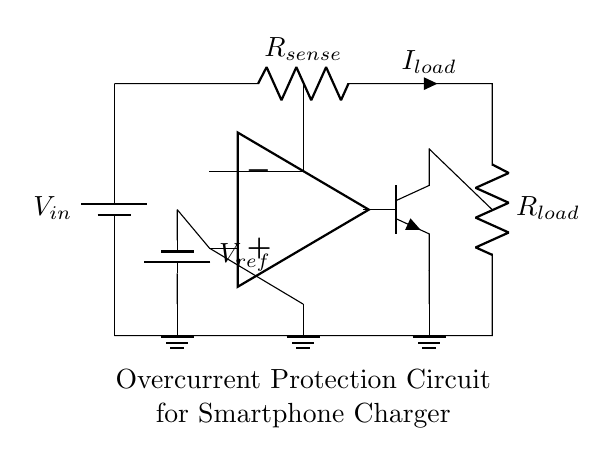What is the function of R sense? R sense is used to measure the current flowing through it, generating a voltage drop proportional to the load current. This voltage is crucial for comparing against a reference voltage to trigger overcurrent protection.
Answer: Current measurement What component is used to limit overcurrent? The transistor is employed to cut off or limit the current when the sensed value exceeds a certain threshold set by the reference voltage.
Answer: Transistor What is the role of the operational amplifier in this circuit? The operational amplifier compares the voltage across R sense (representing load current) with the reference voltage to determine if overcurrent occurs. It outputs a control signal to the transistor based on this comparison.
Answer: Comparator What is the reference voltage value represented in the circuit? The circuit shows a reference voltage connected to the non-inverting input of the operational amplifier, which is crucial in determining whether the load current exceeds the threshold.
Answer: V ref What happens in the circuit when the load current exceeds the reference voltage? When the load current triggers a voltage across R sense that exceeds the reference voltage, the operational amplifier activates the transistor which interrupts the flow of current, preventing damage.
Answer: Current is interrupted 